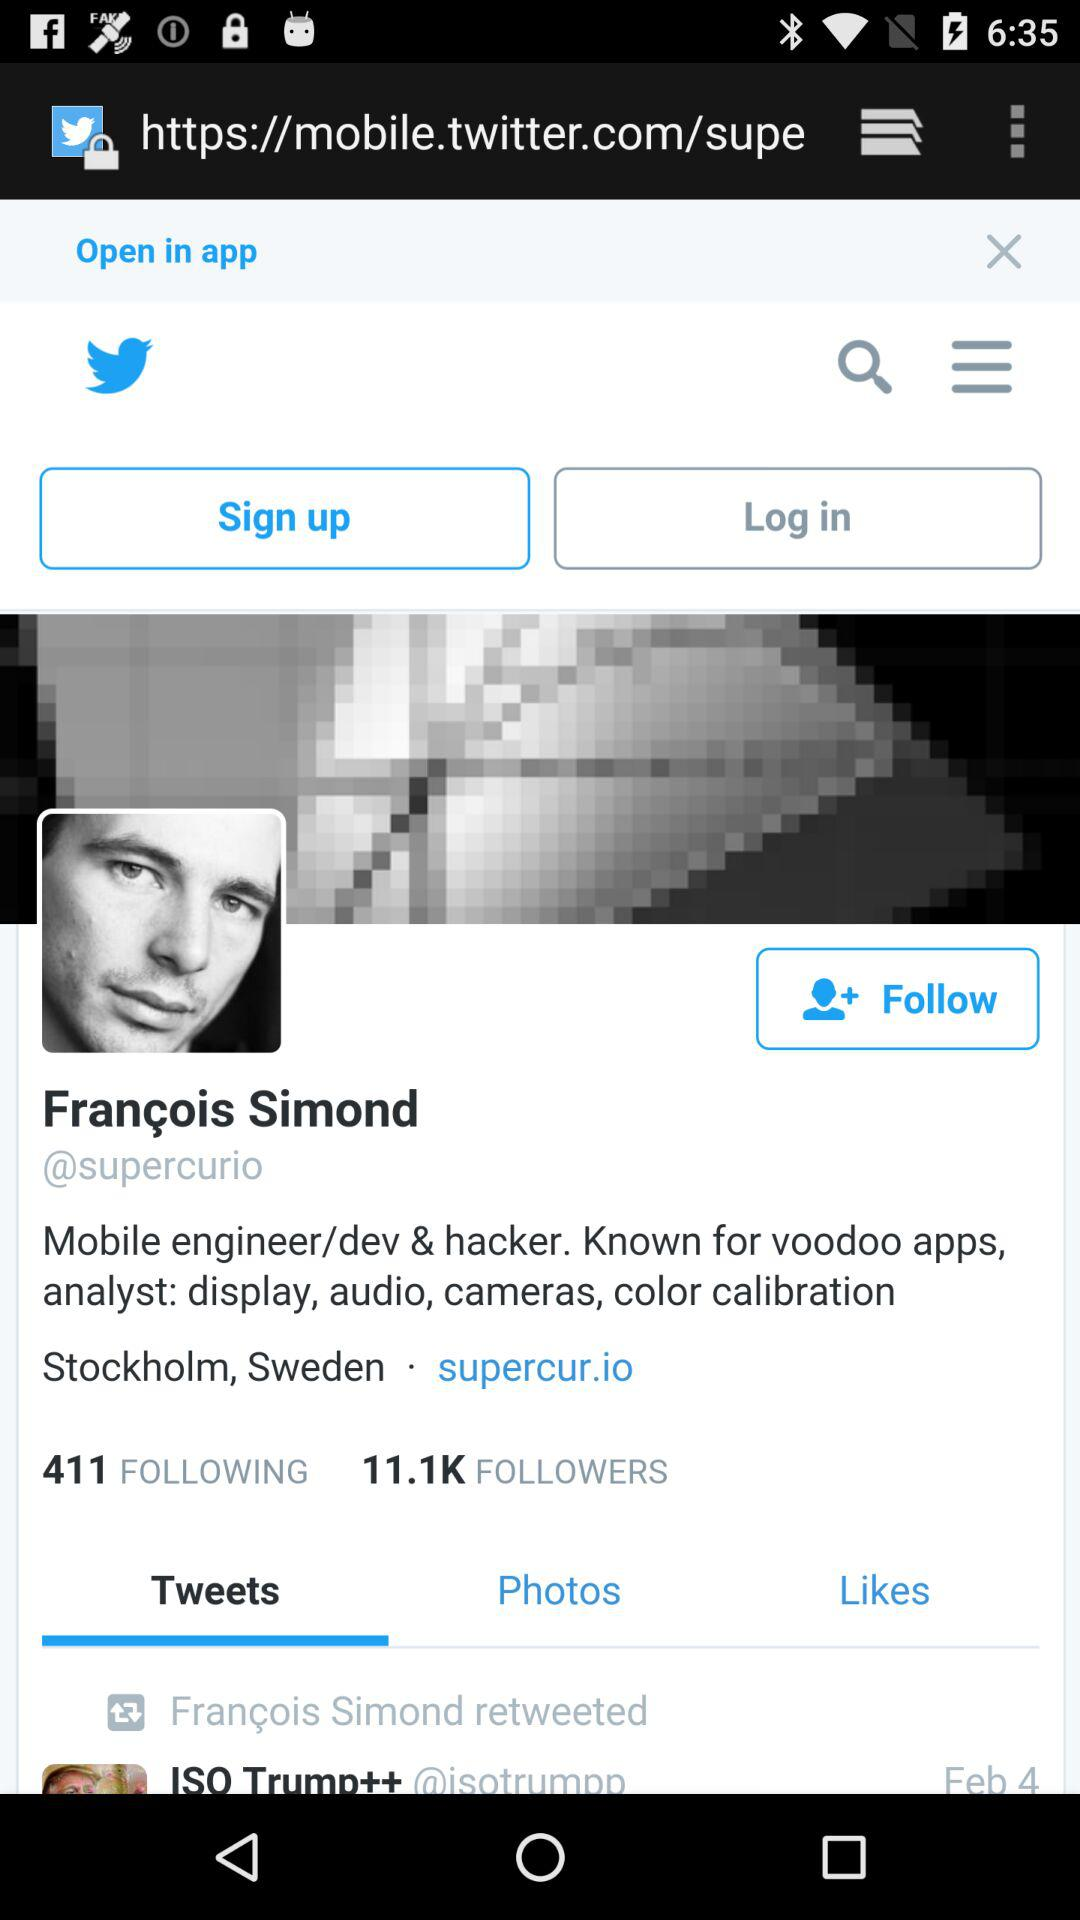How many people does the person follow? The person follows 411 people. 